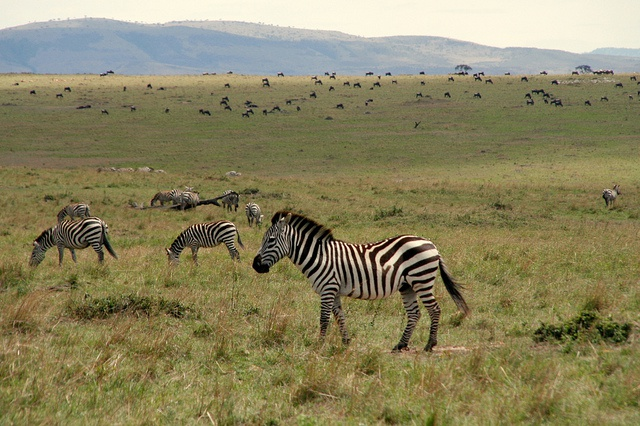Describe the objects in this image and their specific colors. I can see zebra in ivory, black, gray, and darkgray tones, zebra in ivory, black, gray, and darkgreen tones, zebra in ivory, black, and gray tones, zebra in ivory, gray, and black tones, and zebra in ivory, gray, darkgreen, and black tones in this image. 